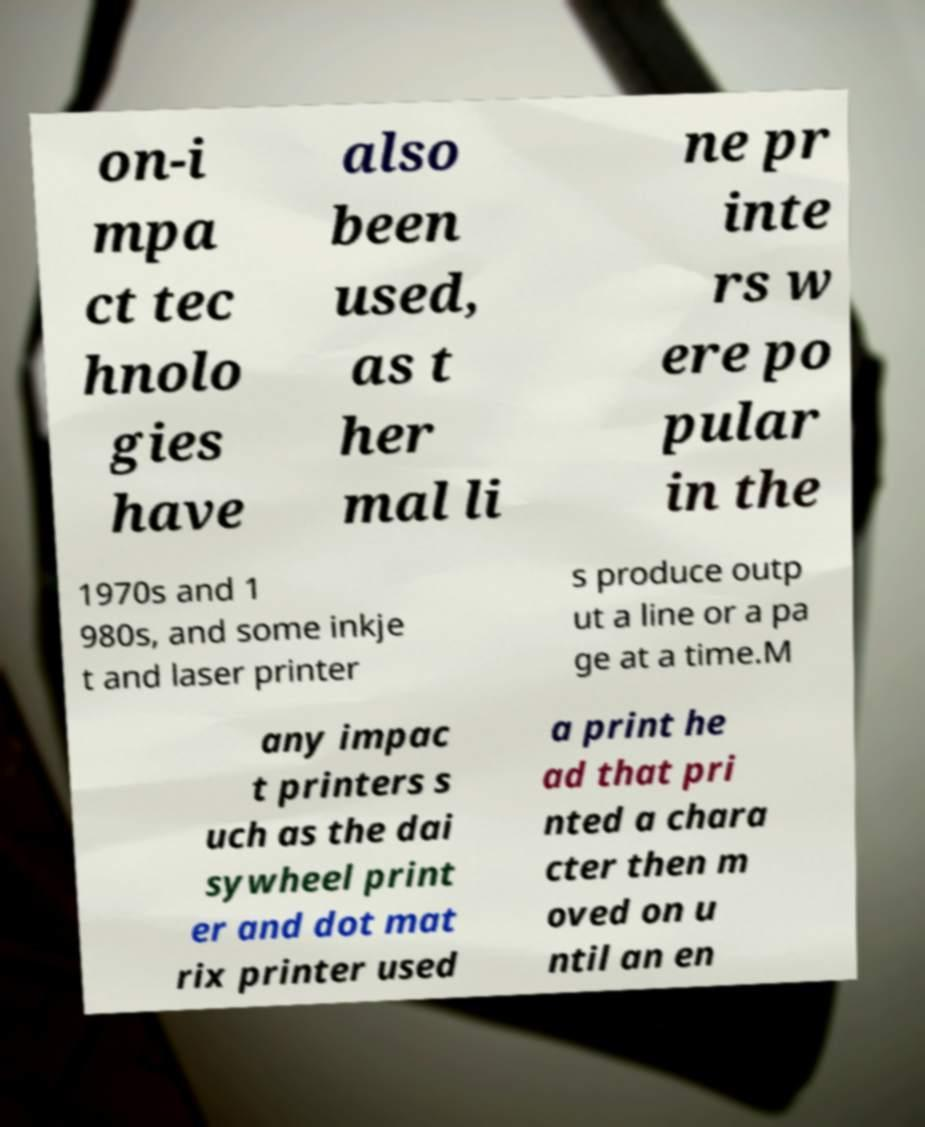What messages or text are displayed in this image? I need them in a readable, typed format. on-i mpa ct tec hnolo gies have also been used, as t her mal li ne pr inte rs w ere po pular in the 1970s and 1 980s, and some inkje t and laser printer s produce outp ut a line or a pa ge at a time.M any impac t printers s uch as the dai sywheel print er and dot mat rix printer used a print he ad that pri nted a chara cter then m oved on u ntil an en 